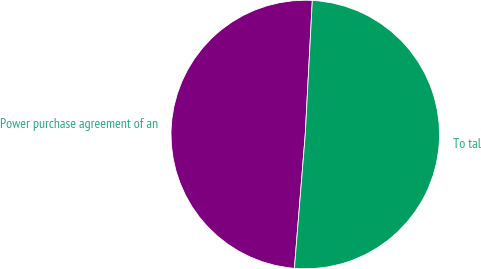Convert chart. <chart><loc_0><loc_0><loc_500><loc_500><pie_chart><fcel>Power purchase agreement of an<fcel>To tal<nl><fcel>49.55%<fcel>50.45%<nl></chart> 